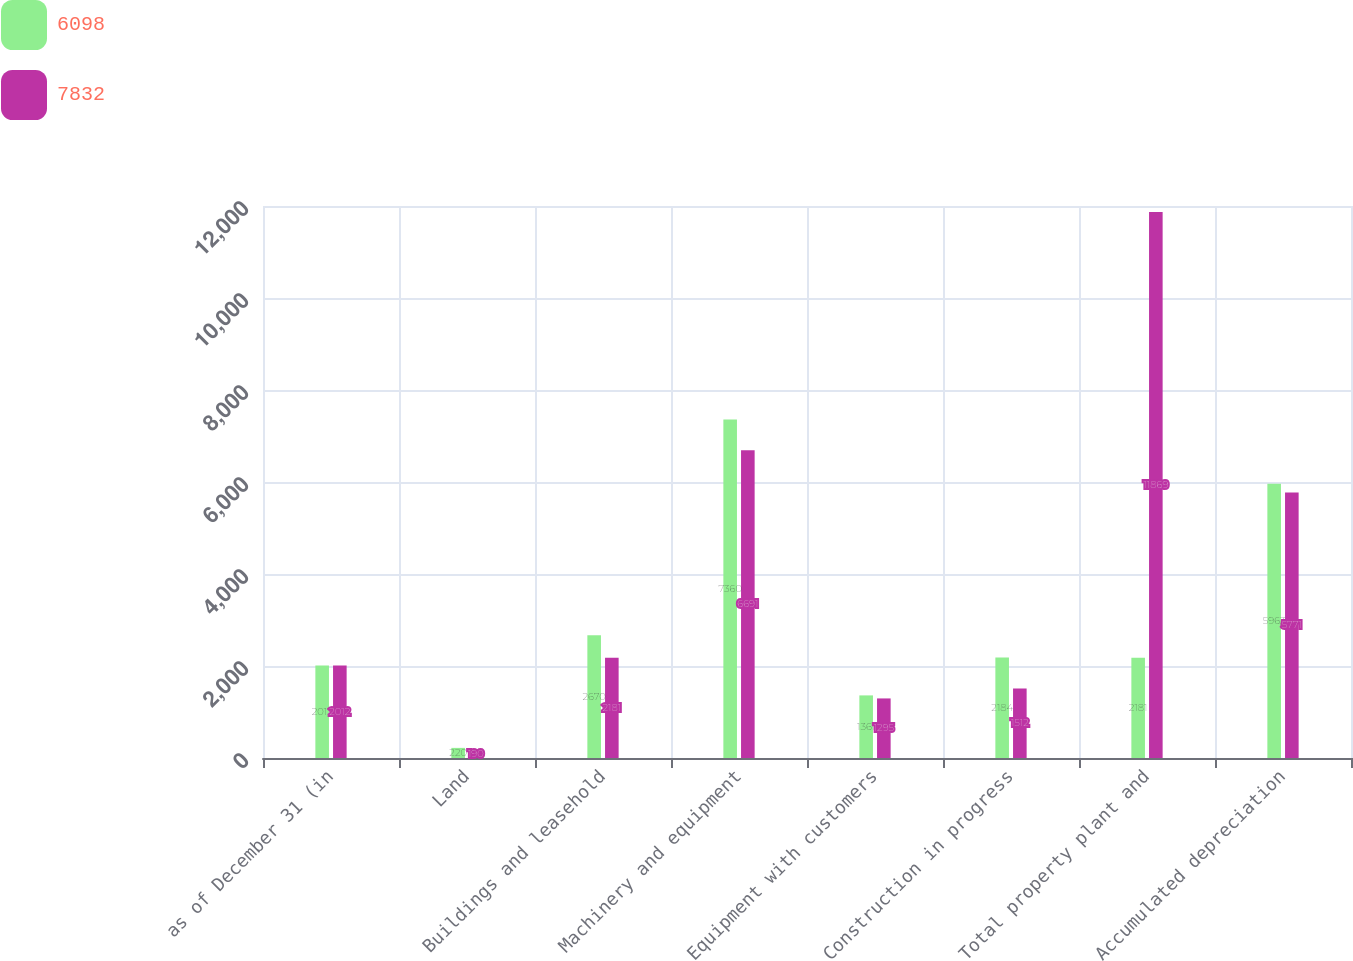Convert chart. <chart><loc_0><loc_0><loc_500><loc_500><stacked_bar_chart><ecel><fcel>as of December 31 (in<fcel>Land<fcel>Buildings and leasehold<fcel>Machinery and equipment<fcel>Equipment with customers<fcel>Construction in progress<fcel>Total property plant and<fcel>Accumulated depreciation<nl><fcel>6098<fcel>2013<fcel>220<fcel>2670<fcel>7360<fcel>1361<fcel>2184<fcel>2181<fcel>5963<nl><fcel>7832<fcel>2012<fcel>190<fcel>2181<fcel>6691<fcel>1295<fcel>1512<fcel>11869<fcel>5771<nl></chart> 